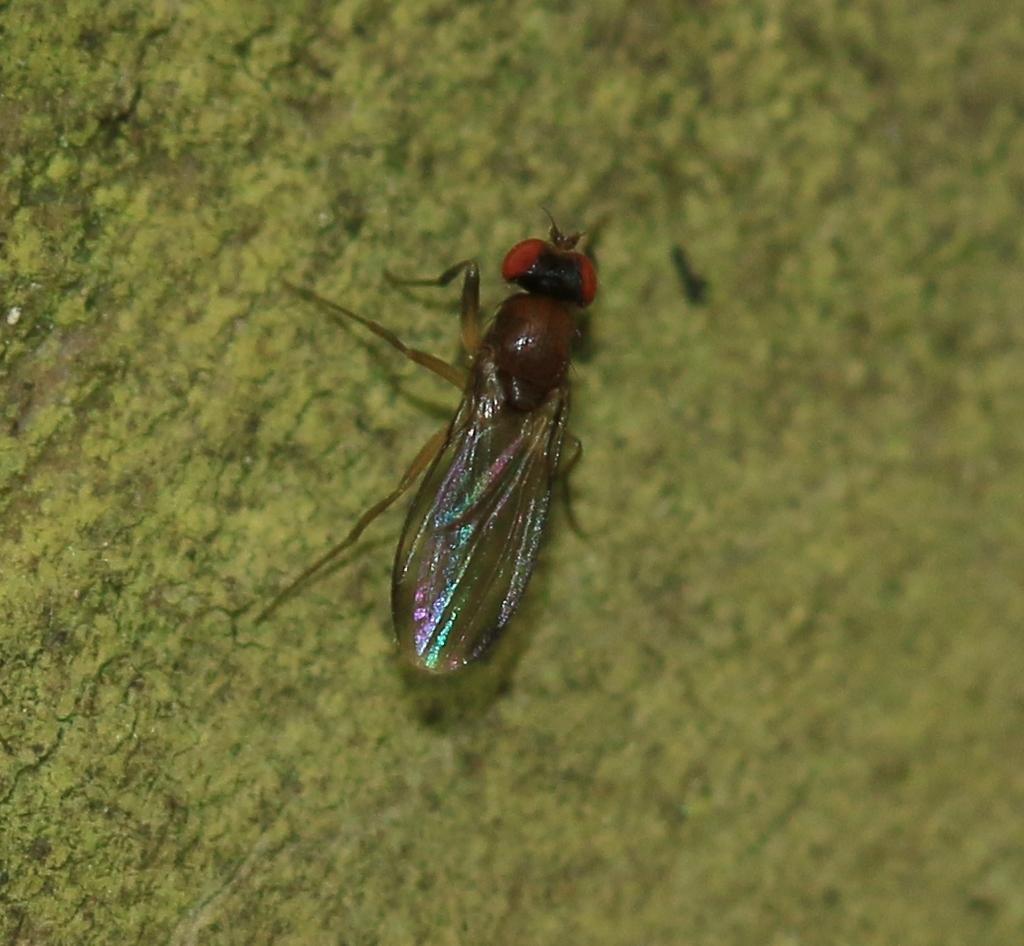Describe this image in one or two sentences. In the middle of the image I can see an insect is on the green surface.   